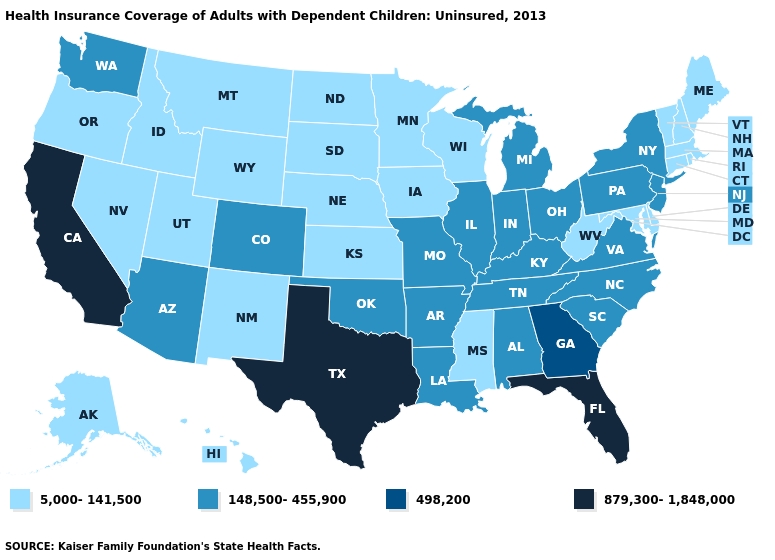Name the states that have a value in the range 879,300-1,848,000?
Give a very brief answer. California, Florida, Texas. Does North Carolina have the lowest value in the USA?
Short answer required. No. Does Georgia have a lower value than Texas?
Write a very short answer. Yes. Does Connecticut have the highest value in the Northeast?
Quick response, please. No. What is the value of Arkansas?
Write a very short answer. 148,500-455,900. Among the states that border Louisiana , which have the highest value?
Keep it brief. Texas. What is the lowest value in the USA?
Write a very short answer. 5,000-141,500. Name the states that have a value in the range 148,500-455,900?
Concise answer only. Alabama, Arizona, Arkansas, Colorado, Illinois, Indiana, Kentucky, Louisiana, Michigan, Missouri, New Jersey, New York, North Carolina, Ohio, Oklahoma, Pennsylvania, South Carolina, Tennessee, Virginia, Washington. Name the states that have a value in the range 879,300-1,848,000?
Be succinct. California, Florida, Texas. Which states have the lowest value in the South?
Quick response, please. Delaware, Maryland, Mississippi, West Virginia. What is the value of Massachusetts?
Concise answer only. 5,000-141,500. Does the map have missing data?
Be succinct. No. Which states have the highest value in the USA?
Be succinct. California, Florida, Texas. Does the map have missing data?
Give a very brief answer. No. Name the states that have a value in the range 5,000-141,500?
Write a very short answer. Alaska, Connecticut, Delaware, Hawaii, Idaho, Iowa, Kansas, Maine, Maryland, Massachusetts, Minnesota, Mississippi, Montana, Nebraska, Nevada, New Hampshire, New Mexico, North Dakota, Oregon, Rhode Island, South Dakota, Utah, Vermont, West Virginia, Wisconsin, Wyoming. 